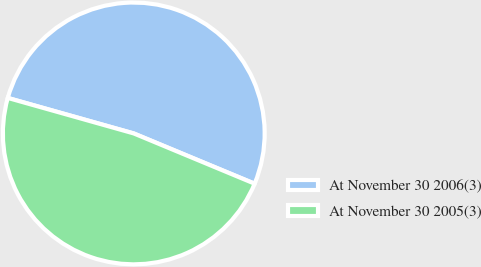Convert chart. <chart><loc_0><loc_0><loc_500><loc_500><pie_chart><fcel>At November 30 2006(3)<fcel>At November 30 2005(3)<nl><fcel>51.9%<fcel>48.1%<nl></chart> 